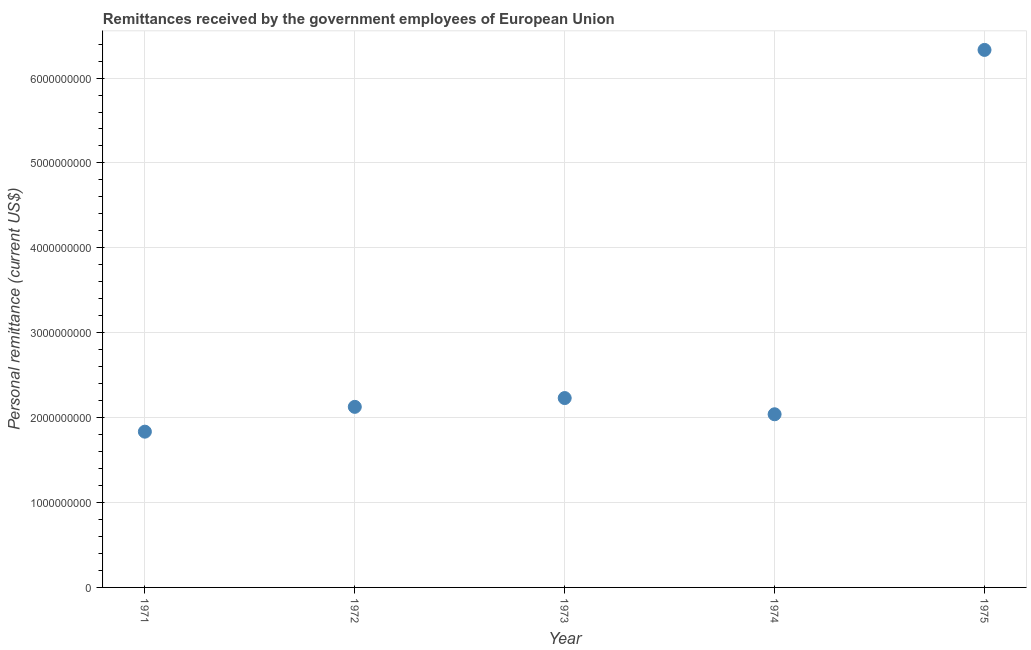What is the personal remittances in 1973?
Give a very brief answer. 2.23e+09. Across all years, what is the maximum personal remittances?
Make the answer very short. 6.33e+09. Across all years, what is the minimum personal remittances?
Your answer should be very brief. 1.83e+09. In which year was the personal remittances maximum?
Ensure brevity in your answer.  1975. What is the sum of the personal remittances?
Provide a succinct answer. 1.46e+1. What is the difference between the personal remittances in 1972 and 1975?
Keep it short and to the point. -4.20e+09. What is the average personal remittances per year?
Keep it short and to the point. 2.91e+09. What is the median personal remittances?
Ensure brevity in your answer.  2.13e+09. In how many years, is the personal remittances greater than 4400000000 US$?
Provide a succinct answer. 1. Do a majority of the years between 1974 and 1971 (inclusive) have personal remittances greater than 6000000000 US$?
Give a very brief answer. Yes. What is the ratio of the personal remittances in 1973 to that in 1974?
Offer a terse response. 1.09. Is the personal remittances in 1972 less than that in 1973?
Your response must be concise. Yes. What is the difference between the highest and the second highest personal remittances?
Keep it short and to the point. 4.10e+09. What is the difference between the highest and the lowest personal remittances?
Your answer should be compact. 4.50e+09. Does the personal remittances monotonically increase over the years?
Provide a succinct answer. No. Are the values on the major ticks of Y-axis written in scientific E-notation?
Give a very brief answer. No. What is the title of the graph?
Your response must be concise. Remittances received by the government employees of European Union. What is the label or title of the X-axis?
Offer a terse response. Year. What is the label or title of the Y-axis?
Give a very brief answer. Personal remittance (current US$). What is the Personal remittance (current US$) in 1971?
Your response must be concise. 1.83e+09. What is the Personal remittance (current US$) in 1972?
Ensure brevity in your answer.  2.13e+09. What is the Personal remittance (current US$) in 1973?
Provide a short and direct response. 2.23e+09. What is the Personal remittance (current US$) in 1974?
Your answer should be compact. 2.04e+09. What is the Personal remittance (current US$) in 1975?
Provide a succinct answer. 6.33e+09. What is the difference between the Personal remittance (current US$) in 1971 and 1972?
Provide a succinct answer. -2.92e+08. What is the difference between the Personal remittance (current US$) in 1971 and 1973?
Your answer should be very brief. -3.96e+08. What is the difference between the Personal remittance (current US$) in 1971 and 1974?
Keep it short and to the point. -2.05e+08. What is the difference between the Personal remittance (current US$) in 1971 and 1975?
Your answer should be very brief. -4.50e+09. What is the difference between the Personal remittance (current US$) in 1972 and 1973?
Your answer should be very brief. -1.04e+08. What is the difference between the Personal remittance (current US$) in 1972 and 1974?
Provide a succinct answer. 8.73e+07. What is the difference between the Personal remittance (current US$) in 1972 and 1975?
Keep it short and to the point. -4.20e+09. What is the difference between the Personal remittance (current US$) in 1973 and 1974?
Make the answer very short. 1.91e+08. What is the difference between the Personal remittance (current US$) in 1973 and 1975?
Provide a succinct answer. -4.10e+09. What is the difference between the Personal remittance (current US$) in 1974 and 1975?
Make the answer very short. -4.29e+09. What is the ratio of the Personal remittance (current US$) in 1971 to that in 1972?
Offer a very short reply. 0.86. What is the ratio of the Personal remittance (current US$) in 1971 to that in 1973?
Provide a succinct answer. 0.82. What is the ratio of the Personal remittance (current US$) in 1971 to that in 1974?
Offer a terse response. 0.9. What is the ratio of the Personal remittance (current US$) in 1971 to that in 1975?
Give a very brief answer. 0.29. What is the ratio of the Personal remittance (current US$) in 1972 to that in 1973?
Keep it short and to the point. 0.95. What is the ratio of the Personal remittance (current US$) in 1972 to that in 1974?
Your response must be concise. 1.04. What is the ratio of the Personal remittance (current US$) in 1972 to that in 1975?
Keep it short and to the point. 0.34. What is the ratio of the Personal remittance (current US$) in 1973 to that in 1974?
Keep it short and to the point. 1.09. What is the ratio of the Personal remittance (current US$) in 1973 to that in 1975?
Provide a succinct answer. 0.35. What is the ratio of the Personal remittance (current US$) in 1974 to that in 1975?
Give a very brief answer. 0.32. 